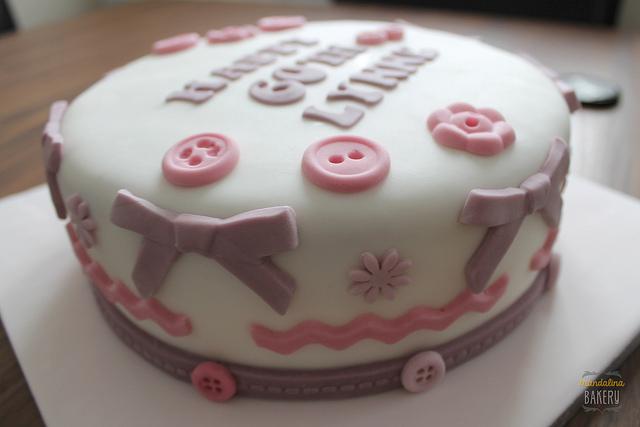What activity must Lynne enjoy doing?
Answer briefly. Sewing. Is there a motor in the cake so that it can rotate on its button wheels?
Give a very brief answer. No. What is the item pictured?
Answer briefly. Cake. 